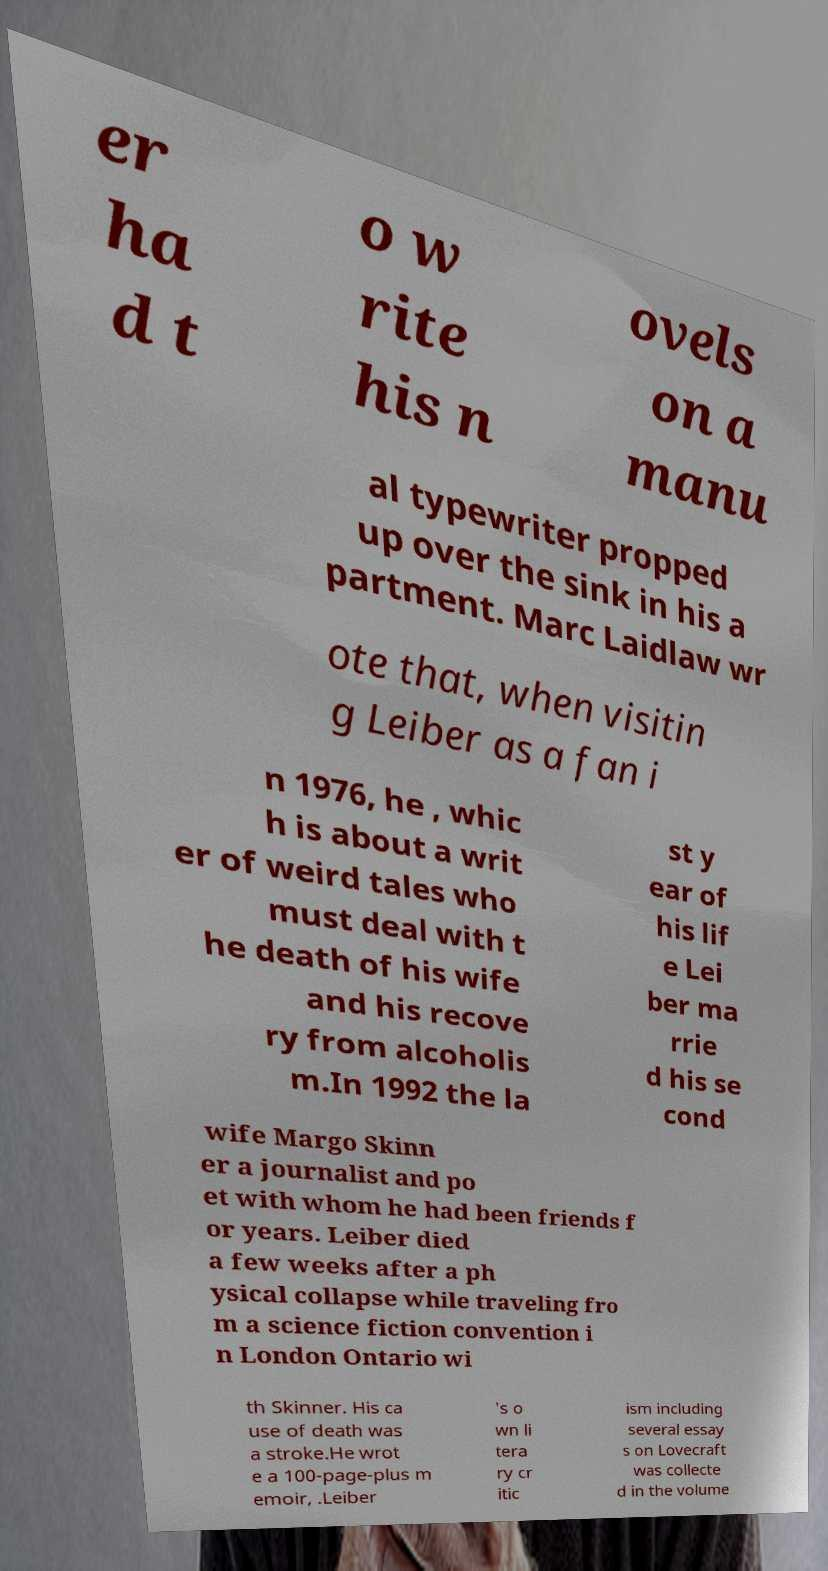For documentation purposes, I need the text within this image transcribed. Could you provide that? er ha d t o w rite his n ovels on a manu al typewriter propped up over the sink in his a partment. Marc Laidlaw wr ote that, when visitin g Leiber as a fan i n 1976, he , whic h is about a writ er of weird tales who must deal with t he death of his wife and his recove ry from alcoholis m.In 1992 the la st y ear of his lif e Lei ber ma rrie d his se cond wife Margo Skinn er a journalist and po et with whom he had been friends f or years. Leiber died a few weeks after a ph ysical collapse while traveling fro m a science fiction convention i n London Ontario wi th Skinner. His ca use of death was a stroke.He wrot e a 100-page-plus m emoir, .Leiber 's o wn li tera ry cr itic ism including several essay s on Lovecraft was collecte d in the volume 